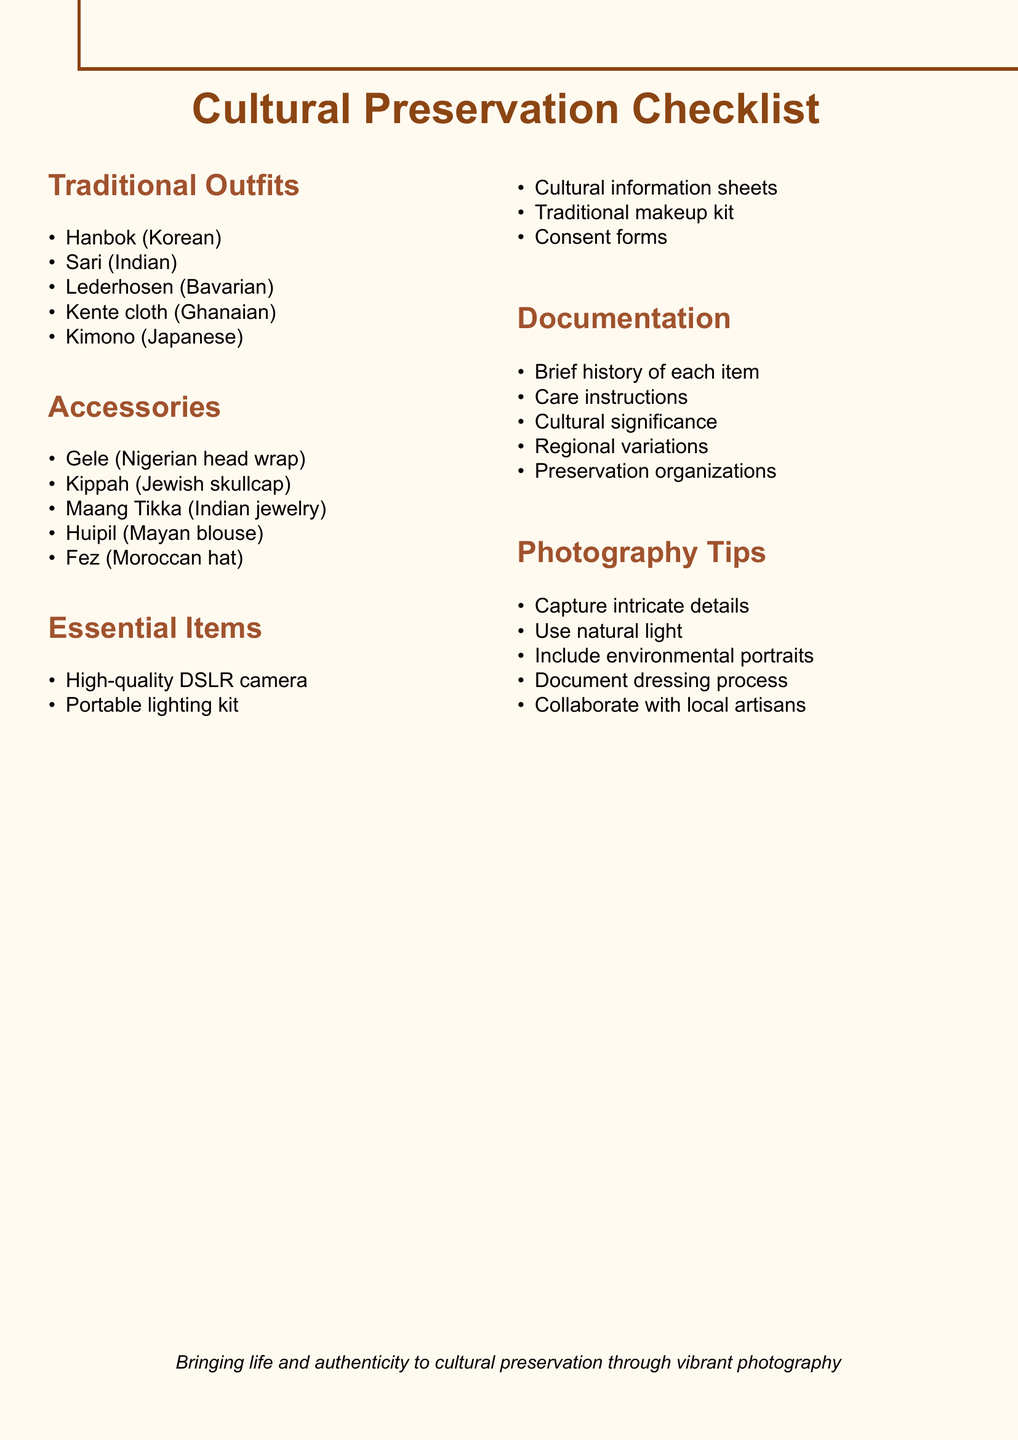What are the traditional outfits listed? The document specifies traditional outfits such as Hanbok, Sari, Lederhosen, Kente cloth, and Kimono.
Answer: Hanbok, Sari, Lederhosen, Kente cloth, Kimono What is one recommended photography tip? The document suggests various photography tips, including capturing intricate details of outfits or using natural light.
Answer: Capture intricate details How many accessories are listed in the document? There are five accessories mentioned in the document, such as Gele and Kippah.
Answer: 5 What item is included in the essential items section? The essential items section lists items like high-quality DSLR camera, portable lighting kit, etc.
Answer: High-quality DSLR camera What cultural item represents Japan? The document highlights traditional outfits, including the Kimono, which represents Japan.
Answer: Kimono What is one aspect covered in the documentation section? The documentation section includes elements like brief history and care instructions for garments.
Answer: Care instructions Which country's traditional fabric is Kente cloth? Kente cloth is identified in the document as a Ghanaian traditional fabric.
Answer: Ghanaian Name a type of headwear mentioned in the accessories list. The accessories list includes items like the Gele, which is a Nigerian head wrap.
Answer: Gele 